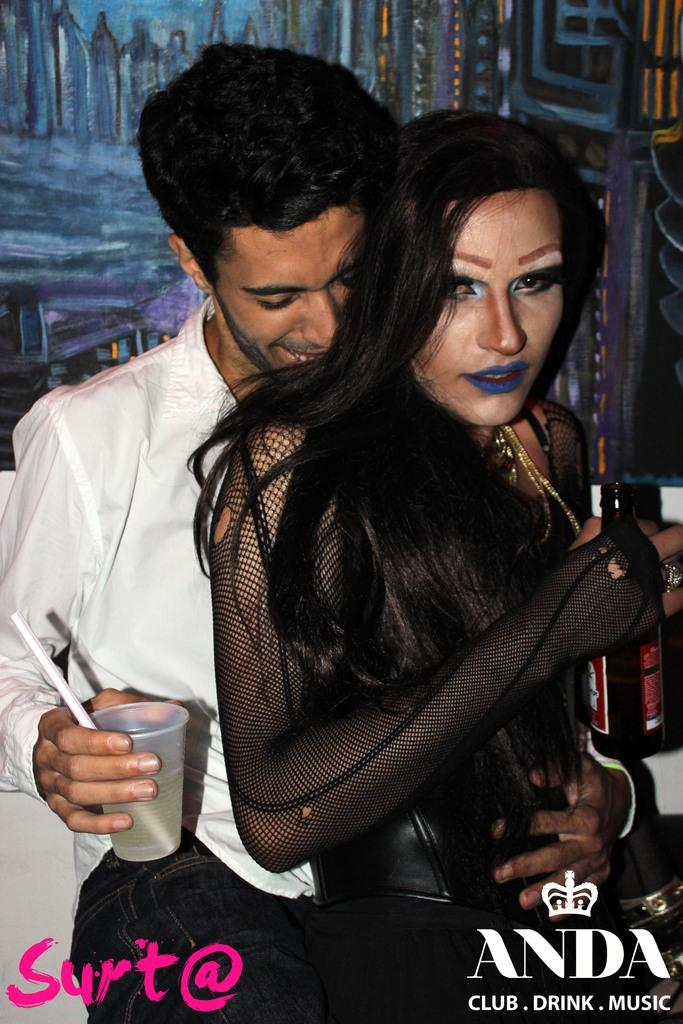How many people are present in the image? There are two people in the image, a man and a woman. What is the man holding in his hand? The man is holding a cup in his hand. What type of plantation is visible in the background of the image? There is no plantation visible in the background of the image. 